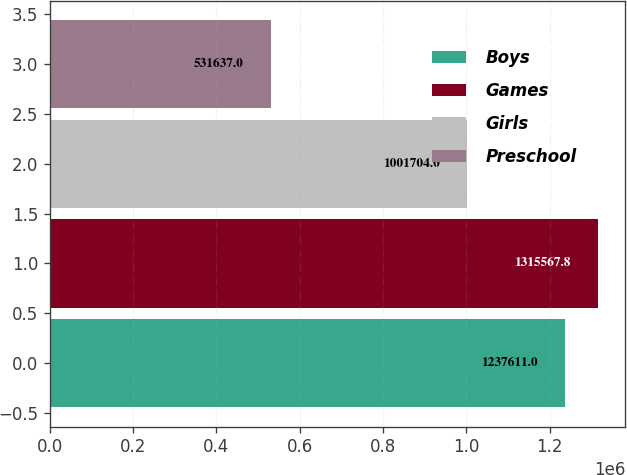Convert chart to OTSL. <chart><loc_0><loc_0><loc_500><loc_500><bar_chart><fcel>Boys<fcel>Games<fcel>Girls<fcel>Preschool<nl><fcel>1.23761e+06<fcel>1.31557e+06<fcel>1.0017e+06<fcel>531637<nl></chart> 